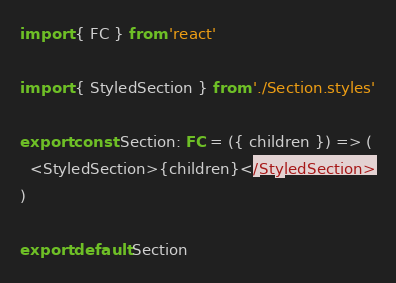<code> <loc_0><loc_0><loc_500><loc_500><_TypeScript_>import { FC } from 'react'

import { StyledSection } from './Section.styles'

export const Section: FC = ({ children }) => (
  <StyledSection>{children}</StyledSection>
)

export default Section
</code> 